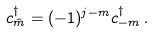<formula> <loc_0><loc_0><loc_500><loc_500>c _ { \bar { m } } ^ { \dagger } = ( - 1 ) ^ { j - m } c _ { - m } ^ { \dagger } \, .</formula> 